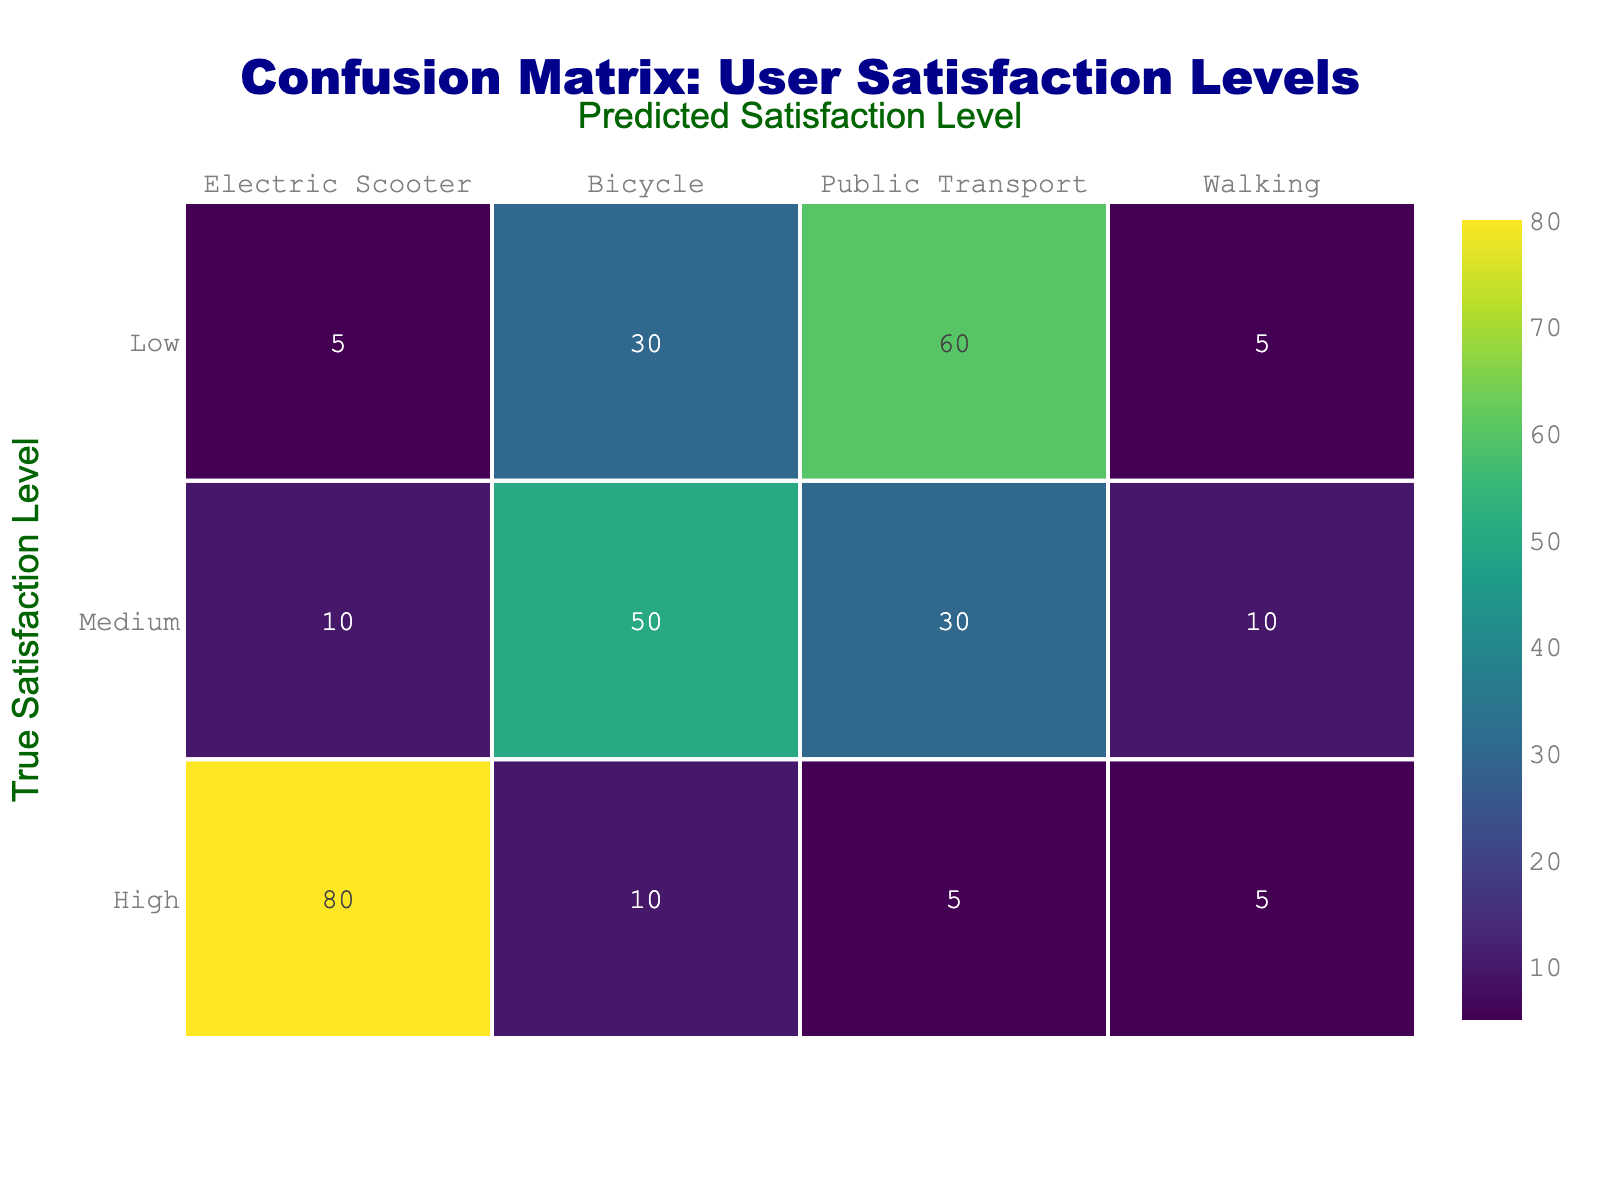What is the predicted satisfaction level for users who truly are in the "High" category? The "High" category shows 80 for Electric Scooters, 10 for Bicycles, 5 for Public Transport, and 5 for Walking. Thus, the predicted satisfaction level for users in the "High" category is primarily represented by Electric Scooters.
Answer: Electric Scooter How many users reported a medium satisfaction level using Bicycles? The "Medium" row indicates there are 50 users who reported a medium satisfaction level using Bicycles.
Answer: 50 Is it true that more users are dissatisfied (Low satisfaction) with Public Transport than with Electric Scooters? Looking at the "Low" row, Public Transport has 60 users dissatisfied while Electric Scooters have only 5. Therefore, it is true that more users are dissatisfied with Public Transport than with Electric Scooters.
Answer: Yes What is the total number of users who reported low satisfaction across all modes? The "Low" row shows the values for each mode: Electric Scooters (5), Bicycles (30), Public Transport (60), and Walking (5). Summing these values gives 5 + 30 + 60 + 5 = 100 users reporting low satisfaction.
Answer: 100 What is the average number of users across all satisfaction levels for Walking? For Walking, the values across satisfaction levels are 5 (High), 10 (Medium), and 5 (Low). Adding these gives 5 + 10 + 5 = 20, and since there are 3 values, the average is 20/3 = 6.67.
Answer: 6.67 How does the number of users that are classified as "High" satisfaction compare to those with "Low" satisfaction for Bicycles? In the Bicycles category, 10 users reported a "High" satisfaction level, while 30 users reported a "Low" level. Comparing the two, we can see there are 30 - 10 = 20 more users reporting low satisfaction than high satisfaction.
Answer: 20 more users in Low Which mode of transport has the least user satisfaction reported in the "High" category? Looking at the "High" category, the values are: Electric Scooters (80), Bicycles (10), Public Transport (5), and Walking (5). The least is reported for Bicycles, with only 10 users.
Answer: Bicycles What percentage of users truly satisfied (High) use Electric Scooters compared to the total reported dissatisfaction (Low) across all modes? The number of users truly satisfied with Electric Scooters is 80. The total dissatisfaction reported (Low) across all modes is 100. To find the percentage, the calculation is (80 / 100) * 100% = 80%.
Answer: 80% If we consider the total number of users categorized as “Medium” and “Low” satisfaction levels, which mode has the highest total? For Medium, the values are Electric Scooters (10), Bicycles (50), Public Transport (30), Walking (10), and for Low: Electric Scooters (5), Bicycles (30), Public Transport (60), Walking (5). So, summing: Bicycles = 50 + 30 = 80; Public Transport = 30 + 60 = 90; thus, Public Transport has the highest total at 90.
Answer: Public Transport 